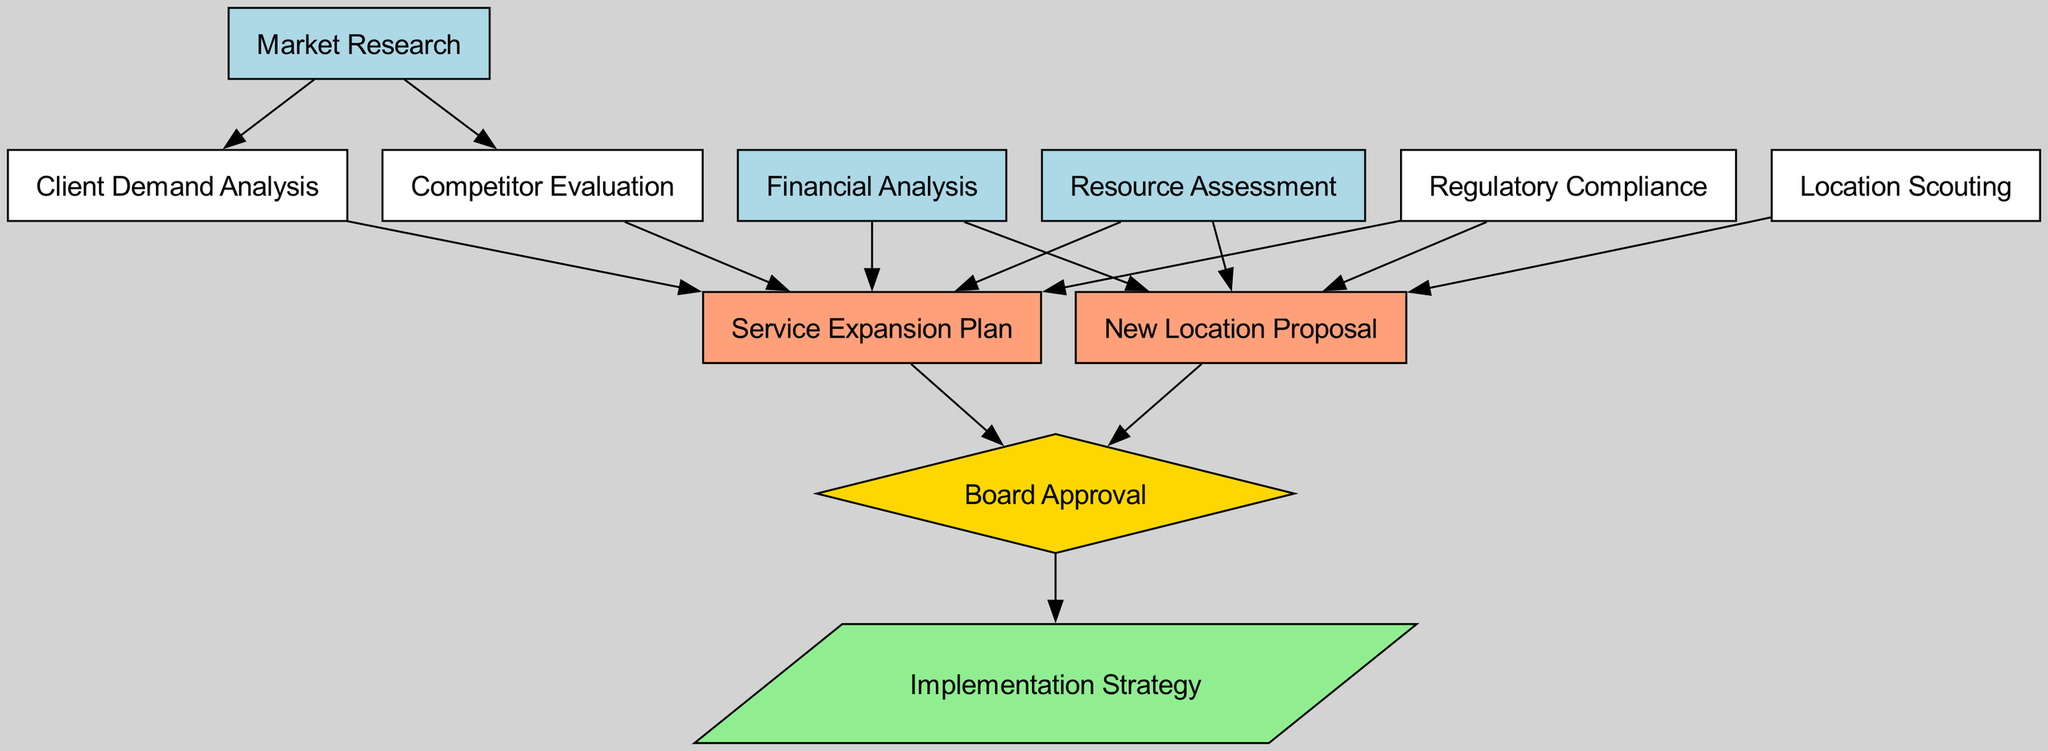What is the starting point of the decision-making process? The diagram indicates that "Market Research" initiates the decision-making process, as it's the first node without any incoming edges.
Answer: Market Research How many nodes are in the diagram? By counting all the distinct nodes listed, we find there are 11 nodes in total that represent different aspects of the decision-making process.
Answer: 11 Which node is shaped like a diamond? The only node shaped like a diamond, indicating a decision point, is "Board Approval". No other nodes share this shape.
Answer: Board Approval What are the two nodes that lead to "Service Expansion Plan"? The nodes that connect to "Service Expansion Plan" through incoming edges are "Financial Analysis" and "Client Demand Analysis". Both contribute directly to this plan.
Answer: Financial Analysis, Client Demand Analysis What is the final step in the decision-making process? The diagram shows that the last step after "Board Approval" is "Implementation Strategy", indicating what follows the approval.
Answer: Implementation Strategy How many edges are there in the diagram? By counting each connection (or edge) between nodes, we determine that there are a total of 13 edges.
Answer: 13 Which pairs of nodes both lead to "New Location Proposal"? The pairs that provide input to "New Location Proposal" are "Financial Analysis" and "Resource Assessment", as well as "Location Scouting". All three nodes lead to this proposal.
Answer: Financial Analysis, Resource Assessment, Location Scouting Which node represents regulatory considerations? The node that focuses on regulations involved in the process is "Regulatory Compliance", indicating that compliance is necessary for both service expansion and new location.
Answer: Regulatory Compliance What node comes directly after "Service Expansion Plan"? Following "Service Expansion Plan", the process moves to "Board Approval" as the next step, denoting that proposals must be approved by the board.
Answer: Board Approval 